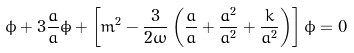Convert formula to latex. <formula><loc_0><loc_0><loc_500><loc_500>\ddot { \phi } + 3 \frac { \dot { a } } { a } \dot { \phi } + \left [ m ^ { 2 } - \frac { 3 } { 2 \omega } \left ( \frac { \ddot { a } } { a } + \frac { \dot { a } ^ { 2 } } { a ^ { 2 } } + \frac { k } { a ^ { 2 } } \right ) \right ] \phi = 0</formula> 